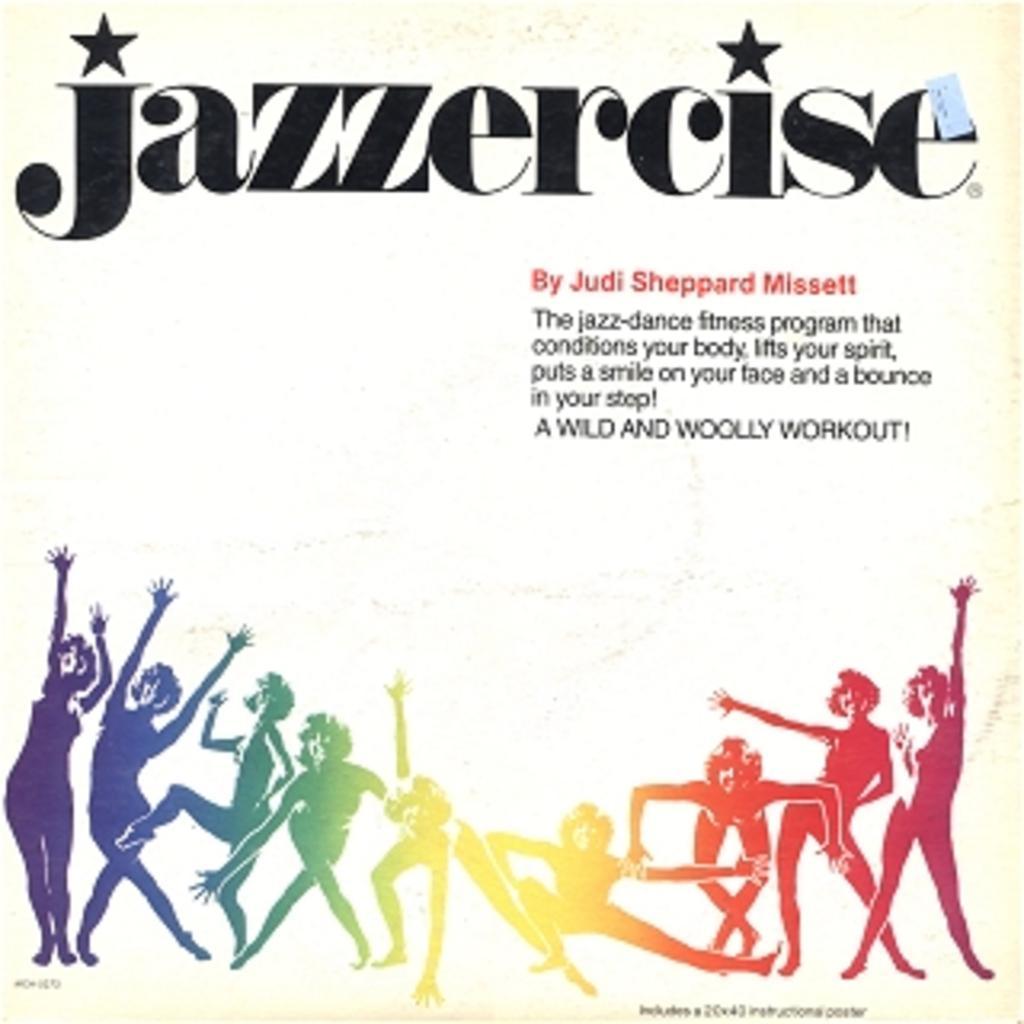Can you describe this image briefly? This is a poster,in this poster we can see persons and text. 